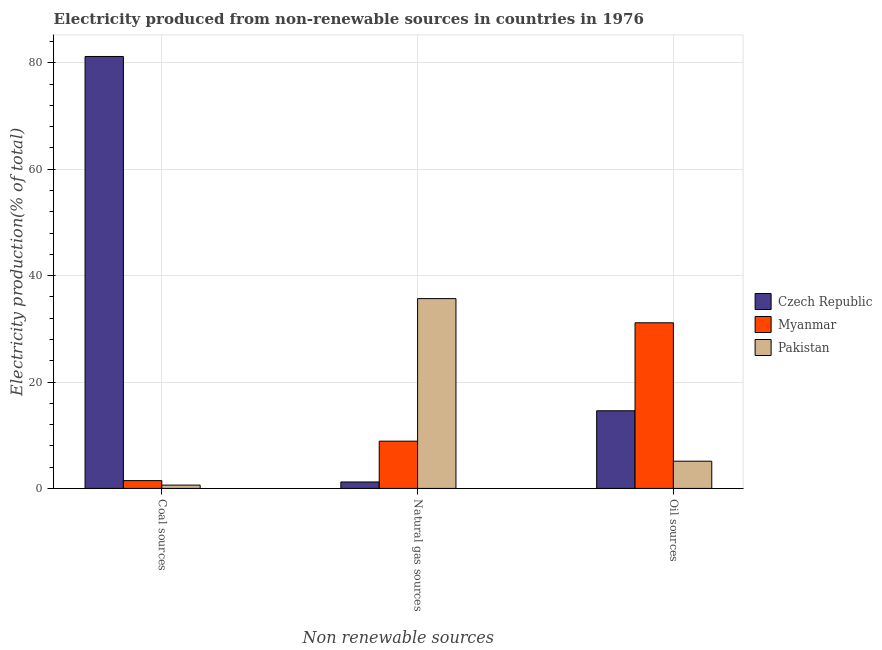How many bars are there on the 1st tick from the left?
Provide a succinct answer. 3. How many bars are there on the 1st tick from the right?
Offer a terse response. 3. What is the label of the 2nd group of bars from the left?
Offer a very short reply. Natural gas sources. What is the percentage of electricity produced by oil sources in Myanmar?
Your response must be concise. 31.14. Across all countries, what is the maximum percentage of electricity produced by coal?
Give a very brief answer. 81.2. Across all countries, what is the minimum percentage of electricity produced by coal?
Provide a short and direct response. 0.62. In which country was the percentage of electricity produced by oil sources maximum?
Provide a succinct answer. Myanmar. In which country was the percentage of electricity produced by oil sources minimum?
Your answer should be very brief. Pakistan. What is the total percentage of electricity produced by natural gas in the graph?
Your answer should be compact. 45.77. What is the difference between the percentage of electricity produced by natural gas in Czech Republic and that in Pakistan?
Keep it short and to the point. -34.47. What is the difference between the percentage of electricity produced by coal in Pakistan and the percentage of electricity produced by oil sources in Myanmar?
Ensure brevity in your answer.  -30.52. What is the average percentage of electricity produced by natural gas per country?
Give a very brief answer. 15.26. What is the difference between the percentage of electricity produced by oil sources and percentage of electricity produced by natural gas in Pakistan?
Offer a very short reply. -30.56. In how many countries, is the percentage of electricity produced by coal greater than 4 %?
Your answer should be compact. 1. What is the ratio of the percentage of electricity produced by natural gas in Myanmar to that in Pakistan?
Your answer should be very brief. 0.25. Is the percentage of electricity produced by natural gas in Myanmar less than that in Pakistan?
Your answer should be compact. Yes. Is the difference between the percentage of electricity produced by oil sources in Czech Republic and Pakistan greater than the difference between the percentage of electricity produced by natural gas in Czech Republic and Pakistan?
Offer a very short reply. Yes. What is the difference between the highest and the second highest percentage of electricity produced by natural gas?
Give a very brief answer. 26.8. What is the difference between the highest and the lowest percentage of electricity produced by oil sources?
Offer a terse response. 26.02. Is the sum of the percentage of electricity produced by coal in Czech Republic and Myanmar greater than the maximum percentage of electricity produced by oil sources across all countries?
Offer a very short reply. Yes. What does the 1st bar from the left in Natural gas sources represents?
Your response must be concise. Czech Republic. How many bars are there?
Ensure brevity in your answer.  9. Are all the bars in the graph horizontal?
Ensure brevity in your answer.  No. How many countries are there in the graph?
Make the answer very short. 3. What is the difference between two consecutive major ticks on the Y-axis?
Your response must be concise. 20. Where does the legend appear in the graph?
Your response must be concise. Center right. How many legend labels are there?
Keep it short and to the point. 3. How are the legend labels stacked?
Make the answer very short. Vertical. What is the title of the graph?
Your answer should be compact. Electricity produced from non-renewable sources in countries in 1976. What is the label or title of the X-axis?
Give a very brief answer. Non renewable sources. What is the Electricity production(% of total) in Czech Republic in Coal sources?
Your answer should be compact. 81.2. What is the Electricity production(% of total) in Myanmar in Coal sources?
Give a very brief answer. 1.47. What is the Electricity production(% of total) in Pakistan in Coal sources?
Ensure brevity in your answer.  0.62. What is the Electricity production(% of total) in Czech Republic in Natural gas sources?
Provide a succinct answer. 1.21. What is the Electricity production(% of total) of Myanmar in Natural gas sources?
Your answer should be very brief. 8.88. What is the Electricity production(% of total) of Pakistan in Natural gas sources?
Your response must be concise. 35.68. What is the Electricity production(% of total) of Czech Republic in Oil sources?
Provide a succinct answer. 14.59. What is the Electricity production(% of total) in Myanmar in Oil sources?
Keep it short and to the point. 31.14. What is the Electricity production(% of total) of Pakistan in Oil sources?
Offer a terse response. 5.12. Across all Non renewable sources, what is the maximum Electricity production(% of total) in Czech Republic?
Give a very brief answer. 81.2. Across all Non renewable sources, what is the maximum Electricity production(% of total) in Myanmar?
Provide a short and direct response. 31.14. Across all Non renewable sources, what is the maximum Electricity production(% of total) in Pakistan?
Your answer should be compact. 35.68. Across all Non renewable sources, what is the minimum Electricity production(% of total) of Czech Republic?
Offer a terse response. 1.21. Across all Non renewable sources, what is the minimum Electricity production(% of total) in Myanmar?
Give a very brief answer. 1.47. Across all Non renewable sources, what is the minimum Electricity production(% of total) of Pakistan?
Provide a short and direct response. 0.62. What is the total Electricity production(% of total) of Czech Republic in the graph?
Offer a very short reply. 97. What is the total Electricity production(% of total) in Myanmar in the graph?
Provide a succinct answer. 41.48. What is the total Electricity production(% of total) of Pakistan in the graph?
Provide a short and direct response. 41.41. What is the difference between the Electricity production(% of total) in Czech Republic in Coal sources and that in Natural gas sources?
Make the answer very short. 79.99. What is the difference between the Electricity production(% of total) of Myanmar in Coal sources and that in Natural gas sources?
Your response must be concise. -7.42. What is the difference between the Electricity production(% of total) of Pakistan in Coal sources and that in Natural gas sources?
Keep it short and to the point. -35.06. What is the difference between the Electricity production(% of total) in Czech Republic in Coal sources and that in Oil sources?
Keep it short and to the point. 66.6. What is the difference between the Electricity production(% of total) of Myanmar in Coal sources and that in Oil sources?
Your response must be concise. -29.67. What is the difference between the Electricity production(% of total) in Pakistan in Coal sources and that in Oil sources?
Offer a very short reply. -4.5. What is the difference between the Electricity production(% of total) of Czech Republic in Natural gas sources and that in Oil sources?
Offer a very short reply. -13.38. What is the difference between the Electricity production(% of total) in Myanmar in Natural gas sources and that in Oil sources?
Keep it short and to the point. -22.25. What is the difference between the Electricity production(% of total) of Pakistan in Natural gas sources and that in Oil sources?
Provide a succinct answer. 30.56. What is the difference between the Electricity production(% of total) of Czech Republic in Coal sources and the Electricity production(% of total) of Myanmar in Natural gas sources?
Offer a terse response. 72.31. What is the difference between the Electricity production(% of total) in Czech Republic in Coal sources and the Electricity production(% of total) in Pakistan in Natural gas sources?
Make the answer very short. 45.52. What is the difference between the Electricity production(% of total) of Myanmar in Coal sources and the Electricity production(% of total) of Pakistan in Natural gas sources?
Provide a short and direct response. -34.21. What is the difference between the Electricity production(% of total) in Czech Republic in Coal sources and the Electricity production(% of total) in Myanmar in Oil sources?
Make the answer very short. 50.06. What is the difference between the Electricity production(% of total) of Czech Republic in Coal sources and the Electricity production(% of total) of Pakistan in Oil sources?
Offer a very short reply. 76.08. What is the difference between the Electricity production(% of total) in Myanmar in Coal sources and the Electricity production(% of total) in Pakistan in Oil sources?
Make the answer very short. -3.65. What is the difference between the Electricity production(% of total) in Czech Republic in Natural gas sources and the Electricity production(% of total) in Myanmar in Oil sources?
Offer a terse response. -29.92. What is the difference between the Electricity production(% of total) of Czech Republic in Natural gas sources and the Electricity production(% of total) of Pakistan in Oil sources?
Give a very brief answer. -3.91. What is the difference between the Electricity production(% of total) of Myanmar in Natural gas sources and the Electricity production(% of total) of Pakistan in Oil sources?
Ensure brevity in your answer.  3.77. What is the average Electricity production(% of total) in Czech Republic per Non renewable sources?
Offer a very short reply. 32.33. What is the average Electricity production(% of total) of Myanmar per Non renewable sources?
Offer a terse response. 13.83. What is the average Electricity production(% of total) in Pakistan per Non renewable sources?
Offer a terse response. 13.8. What is the difference between the Electricity production(% of total) of Czech Republic and Electricity production(% of total) of Myanmar in Coal sources?
Your answer should be very brief. 79.73. What is the difference between the Electricity production(% of total) in Czech Republic and Electricity production(% of total) in Pakistan in Coal sources?
Your answer should be compact. 80.58. What is the difference between the Electricity production(% of total) in Myanmar and Electricity production(% of total) in Pakistan in Coal sources?
Provide a short and direct response. 0.84. What is the difference between the Electricity production(% of total) of Czech Republic and Electricity production(% of total) of Myanmar in Natural gas sources?
Your response must be concise. -7.67. What is the difference between the Electricity production(% of total) of Czech Republic and Electricity production(% of total) of Pakistan in Natural gas sources?
Keep it short and to the point. -34.47. What is the difference between the Electricity production(% of total) in Myanmar and Electricity production(% of total) in Pakistan in Natural gas sources?
Your response must be concise. -26.8. What is the difference between the Electricity production(% of total) of Czech Republic and Electricity production(% of total) of Myanmar in Oil sources?
Provide a short and direct response. -16.54. What is the difference between the Electricity production(% of total) of Czech Republic and Electricity production(% of total) of Pakistan in Oil sources?
Offer a terse response. 9.48. What is the difference between the Electricity production(% of total) in Myanmar and Electricity production(% of total) in Pakistan in Oil sources?
Ensure brevity in your answer.  26.02. What is the ratio of the Electricity production(% of total) of Czech Republic in Coal sources to that in Natural gas sources?
Keep it short and to the point. 67.05. What is the ratio of the Electricity production(% of total) of Myanmar in Coal sources to that in Natural gas sources?
Give a very brief answer. 0.16. What is the ratio of the Electricity production(% of total) of Pakistan in Coal sources to that in Natural gas sources?
Offer a terse response. 0.02. What is the ratio of the Electricity production(% of total) of Czech Republic in Coal sources to that in Oil sources?
Make the answer very short. 5.56. What is the ratio of the Electricity production(% of total) in Myanmar in Coal sources to that in Oil sources?
Make the answer very short. 0.05. What is the ratio of the Electricity production(% of total) in Pakistan in Coal sources to that in Oil sources?
Ensure brevity in your answer.  0.12. What is the ratio of the Electricity production(% of total) in Czech Republic in Natural gas sources to that in Oil sources?
Provide a succinct answer. 0.08. What is the ratio of the Electricity production(% of total) in Myanmar in Natural gas sources to that in Oil sources?
Offer a terse response. 0.29. What is the ratio of the Electricity production(% of total) in Pakistan in Natural gas sources to that in Oil sources?
Your response must be concise. 6.97. What is the difference between the highest and the second highest Electricity production(% of total) of Czech Republic?
Provide a short and direct response. 66.6. What is the difference between the highest and the second highest Electricity production(% of total) of Myanmar?
Offer a very short reply. 22.25. What is the difference between the highest and the second highest Electricity production(% of total) of Pakistan?
Give a very brief answer. 30.56. What is the difference between the highest and the lowest Electricity production(% of total) in Czech Republic?
Ensure brevity in your answer.  79.99. What is the difference between the highest and the lowest Electricity production(% of total) in Myanmar?
Provide a short and direct response. 29.67. What is the difference between the highest and the lowest Electricity production(% of total) of Pakistan?
Offer a very short reply. 35.06. 